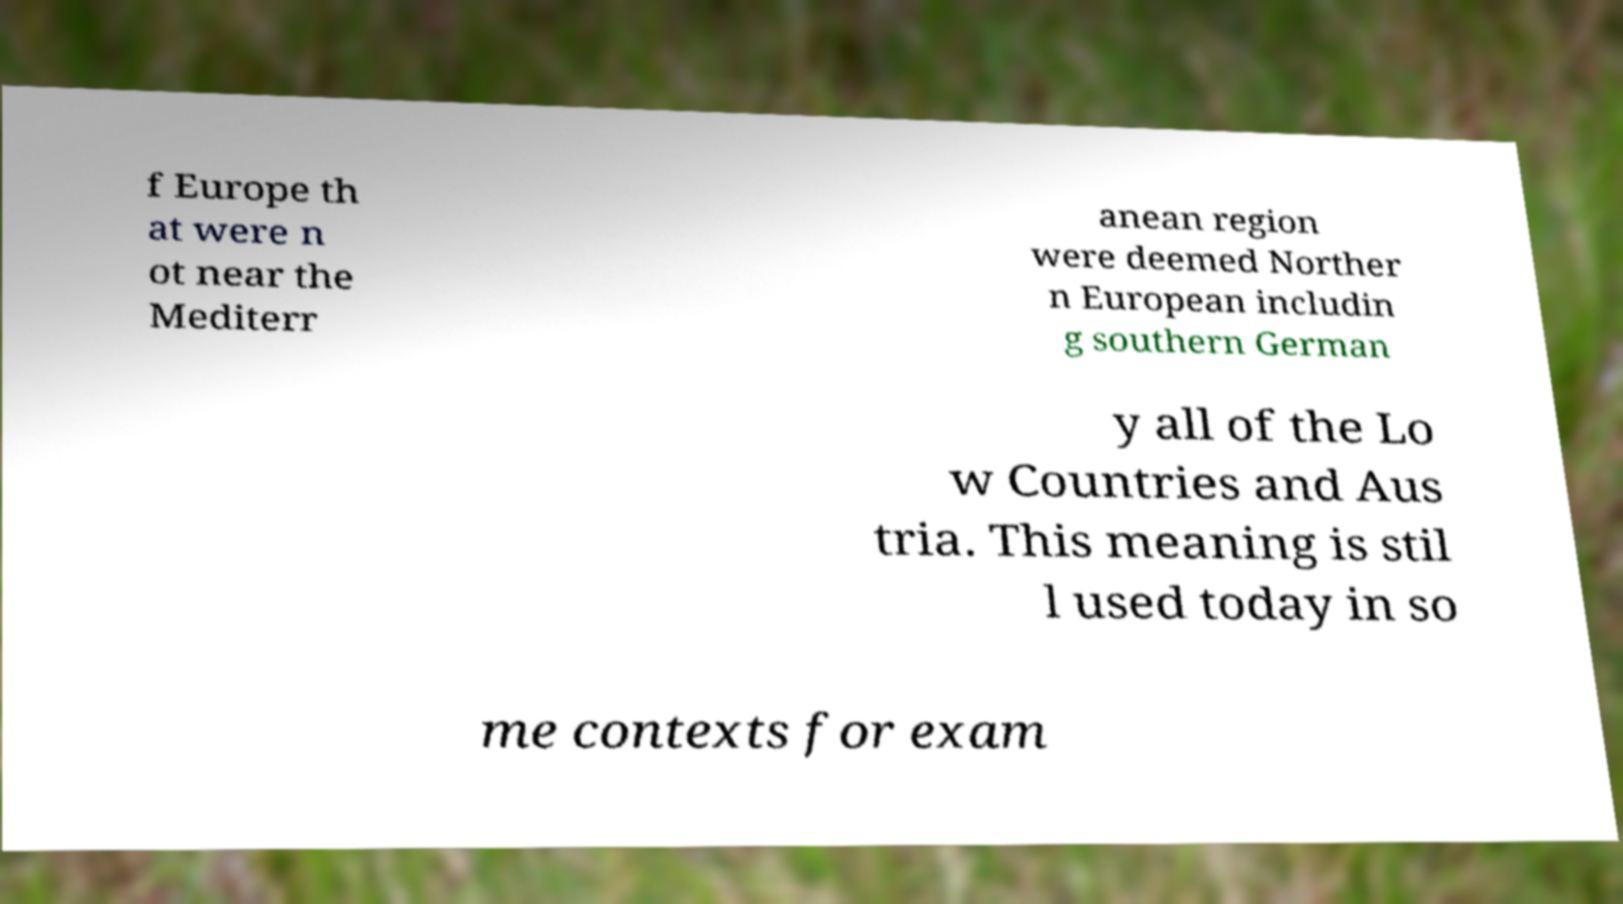Please identify and transcribe the text found in this image. f Europe th at were n ot near the Mediterr anean region were deemed Norther n European includin g southern German y all of the Lo w Countries and Aus tria. This meaning is stil l used today in so me contexts for exam 